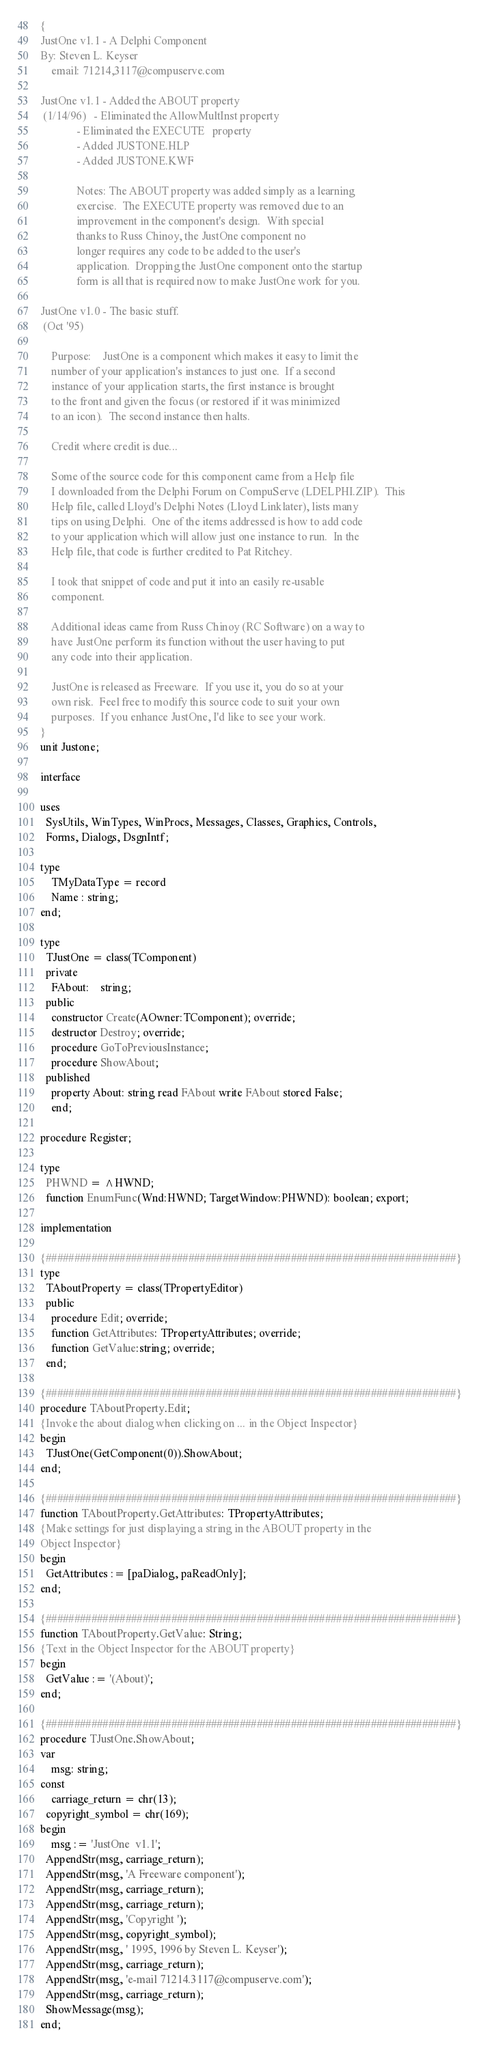<code> <loc_0><loc_0><loc_500><loc_500><_Pascal_>

{
JustOne v1.1 - A Delphi Component
By: Steven L. Keyser
    email: 71214,3117@compuserve.com

JustOne v1.1 - Added the ABOUT property
 (1/14/96)	 - Eliminated the AllowMultInst property
             - Eliminated the EXECUTE	property
             - Added JUSTONE.HLP
             - Added JUSTONE.KWF

             Notes: The ABOUT property was added simply as a learning
             exercise.  The EXECUTE property was removed due to an
             improvement in the component's design.  With special
             thanks to Russ Chinoy, the JustOne component no
             longer requires any code to be added to the user's
             application.  Dropping the JustOne component onto the startup
             form is all that is required now to make JustOne work for you.

JustOne v1.0 - The basic stuff.
 (Oct '95)

    Purpose:	JustOne is a component which makes it easy to limit the
    number of your application's instances to just one.  If a second
    instance of your application starts, the first instance is brought
    to the front and given the focus (or restored if it was minimized
    to an icon).  The second instance then halts.

    Credit where credit is due...

    Some of the source code for this component came from a Help file
    I downloaded from the Delphi Forum on CompuServe (LDELPHI.ZIP).  This
    Help file, called Lloyd's Delphi Notes (Lloyd Linklater), lists many
    tips on using Delphi.  One of the items addressed is how to add code
    to your application which will allow just one instance to run.  In the
    Help file, that code is further credited to Pat Ritchey.

    I took that snippet of code and put it into an easily re-usable
    component.

    Additional ideas came from Russ Chinoy (RC Software) on a way to
    have JustOne perform its function without the user having to put
    any code into their application.

    JustOne is released as Freeware.  If you use it, you do so at your
    own risk.  Feel free to modify this source code to suit your own
    purposes.  If you enhance JustOne, I'd like to see your work.
}
unit Justone;

interface

uses
  SysUtils, WinTypes, WinProcs, Messages, Classes, Graphics, Controls,
  Forms, Dialogs, DsgnIntf;

type
	TMyDataType = record
	Name : string;
end;

type
  TJustOne = class(TComponent)
  private
    FAbout:	string;
  public
    constructor Create(AOwner:TComponent); override;
    destructor Destroy; override;
    procedure GoToPreviousInstance;
    procedure ShowAbout;
  published
    property About: string read FAbout write FAbout stored False;
	end;

procedure Register;

type
  PHWND = ^HWND;
  function EnumFunc(Wnd:HWND; TargetWindow:PHWND): boolean; export;

implementation

{########################################################################}
type
  TAboutProperty = class(TPropertyEditor)
  public
    procedure Edit; override;
    function GetAttributes: TPropertyAttributes; override;
    function GetValue:string; override;
  end;

{########################################################################}
procedure TAboutProperty.Edit;
{Invoke the about dialog when clicking on ... in the Object Inspector}
begin
  TJustOne(GetComponent(0)).ShowAbout;
end;

{########################################################################}
function TAboutProperty.GetAttributes: TPropertyAttributes;
{Make settings for just displaying a string in the ABOUT property in the
Object Inspector}
begin
  GetAttributes := [paDialog, paReadOnly];
end;

{########################################################################}
function TAboutProperty.GetValue: String;
{Text in the Object Inspector for the ABOUT property}
begin
  GetValue := '(About)';
end;

{########################################################################}
procedure TJustOne.ShowAbout;
var
	msg: string;
const
	carriage_return = chr(13);
  copyright_symbol = chr(169);
begin
	msg := 'JustOne  v1.1';
  AppendStr(msg, carriage_return);
  AppendStr(msg, 'A Freeware component');
  AppendStr(msg, carriage_return);
  AppendStr(msg, carriage_return);
  AppendStr(msg, 'Copyright ');
  AppendStr(msg, copyright_symbol);
  AppendStr(msg, ' 1995, 1996 by Steven L. Keyser');
  AppendStr(msg, carriage_return);
  AppendStr(msg, 'e-mail 71214.3117@compuserve.com');
  AppendStr(msg, carriage_return);
  ShowMessage(msg);
end;
</code> 